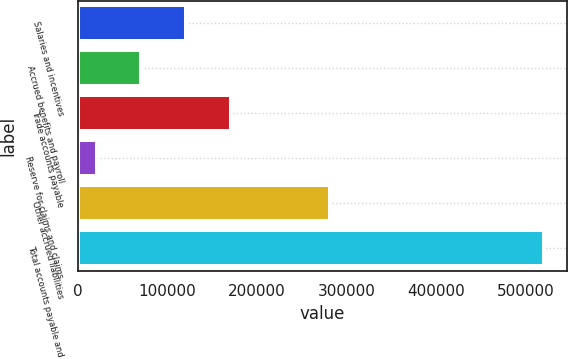<chart> <loc_0><loc_0><loc_500><loc_500><bar_chart><fcel>Salaries and incentives<fcel>Accrued benefits and payroll<fcel>Trade accounts payable<fcel>Reserve for claims and claims<fcel>Other accrued liabilities<fcel>Total accounts payable and<nl><fcel>120870<fcel>70977.2<fcel>170764<fcel>21084<fcel>281434<fcel>520016<nl></chart> 